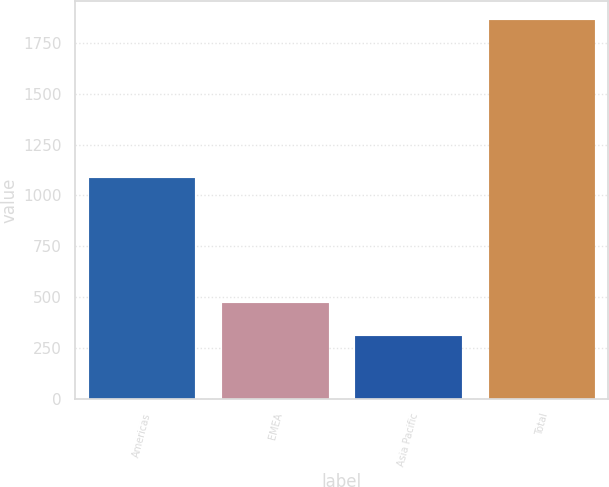<chart> <loc_0><loc_0><loc_500><loc_500><bar_chart><fcel>Americas<fcel>EMEA<fcel>Asia Pacific<fcel>Total<nl><fcel>1087.5<fcel>468.4<fcel>306.3<fcel>1862.2<nl></chart> 